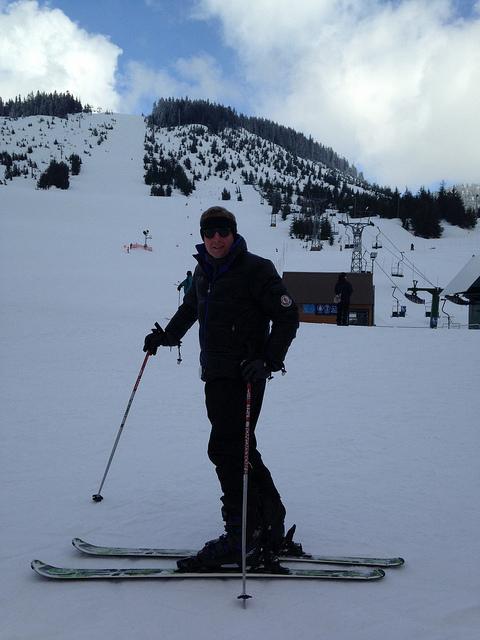Is this person about to ski down a big hill?
Keep it brief. No. Is the sky clear?
Be succinct. No. What does this man have on his back?
Quick response, please. Jacket. Is the man wearing sunglasses?
Keep it brief. Yes. What is the man holding?
Keep it brief. Ski poles. 